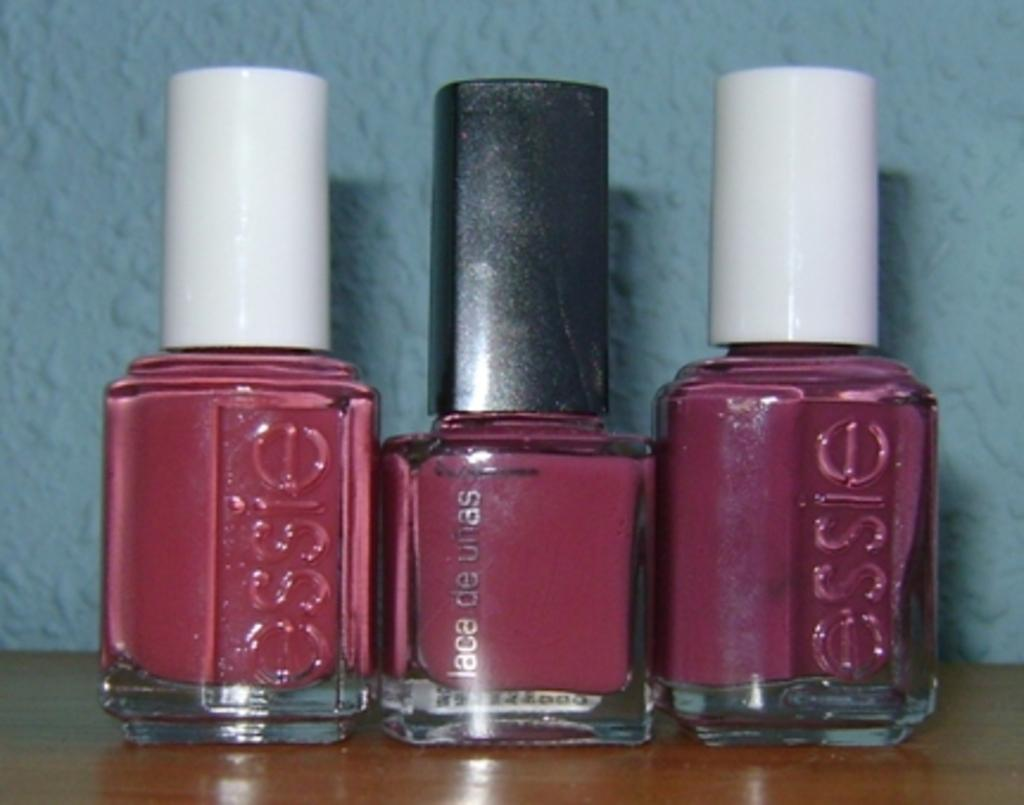What objects are visible in the image? There are nail polish containers in the image. Where are the nail polish containers located? The nail polish containers are placed on a table. What can be seen in the background of the image? There is a wall in the background of the image. How many cattle can be seen in the image? There are no cattle present in the image. What is the stomach doing in the image? There is no stomach present in the image. 